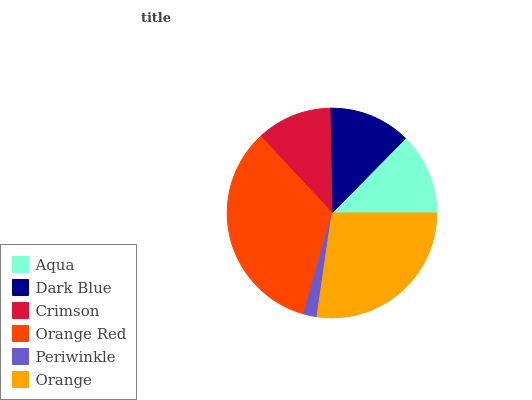Is Periwinkle the minimum?
Answer yes or no. Yes. Is Orange Red the maximum?
Answer yes or no. Yes. Is Dark Blue the minimum?
Answer yes or no. No. Is Dark Blue the maximum?
Answer yes or no. No. Is Dark Blue greater than Aqua?
Answer yes or no. Yes. Is Aqua less than Dark Blue?
Answer yes or no. Yes. Is Aqua greater than Dark Blue?
Answer yes or no. No. Is Dark Blue less than Aqua?
Answer yes or no. No. Is Dark Blue the high median?
Answer yes or no. Yes. Is Aqua the low median?
Answer yes or no. Yes. Is Orange the high median?
Answer yes or no. No. Is Crimson the low median?
Answer yes or no. No. 